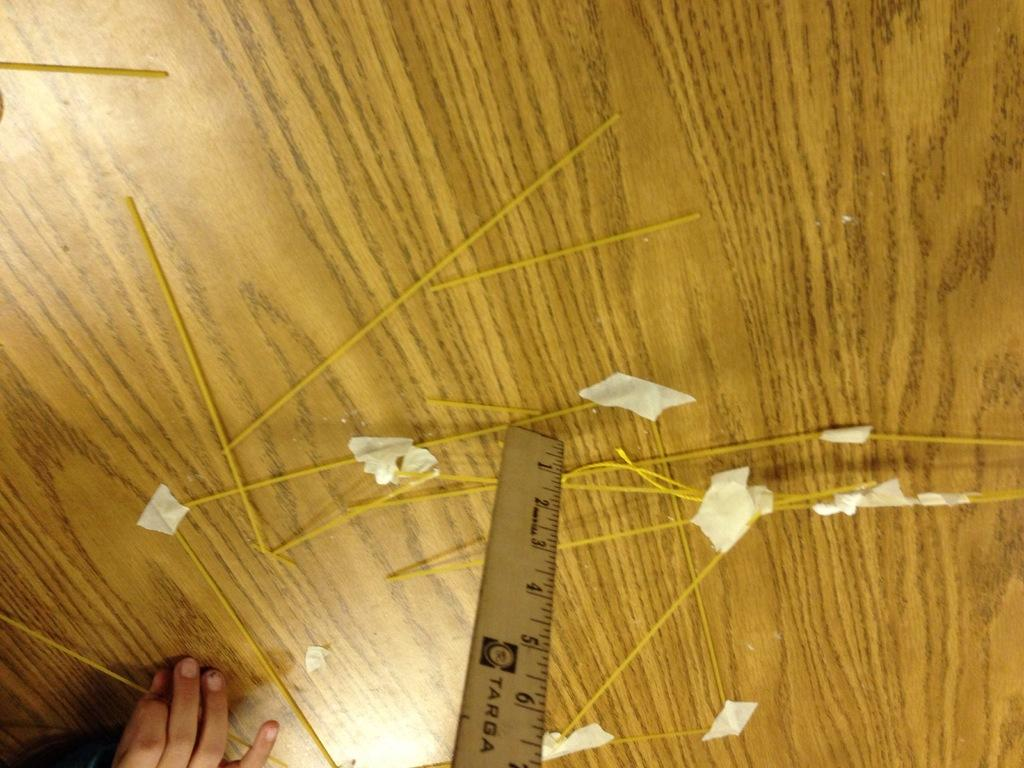<image>
Write a terse but informative summary of the picture. A person has raw spaghetti noodles and measuring something with a Targa ruler. 